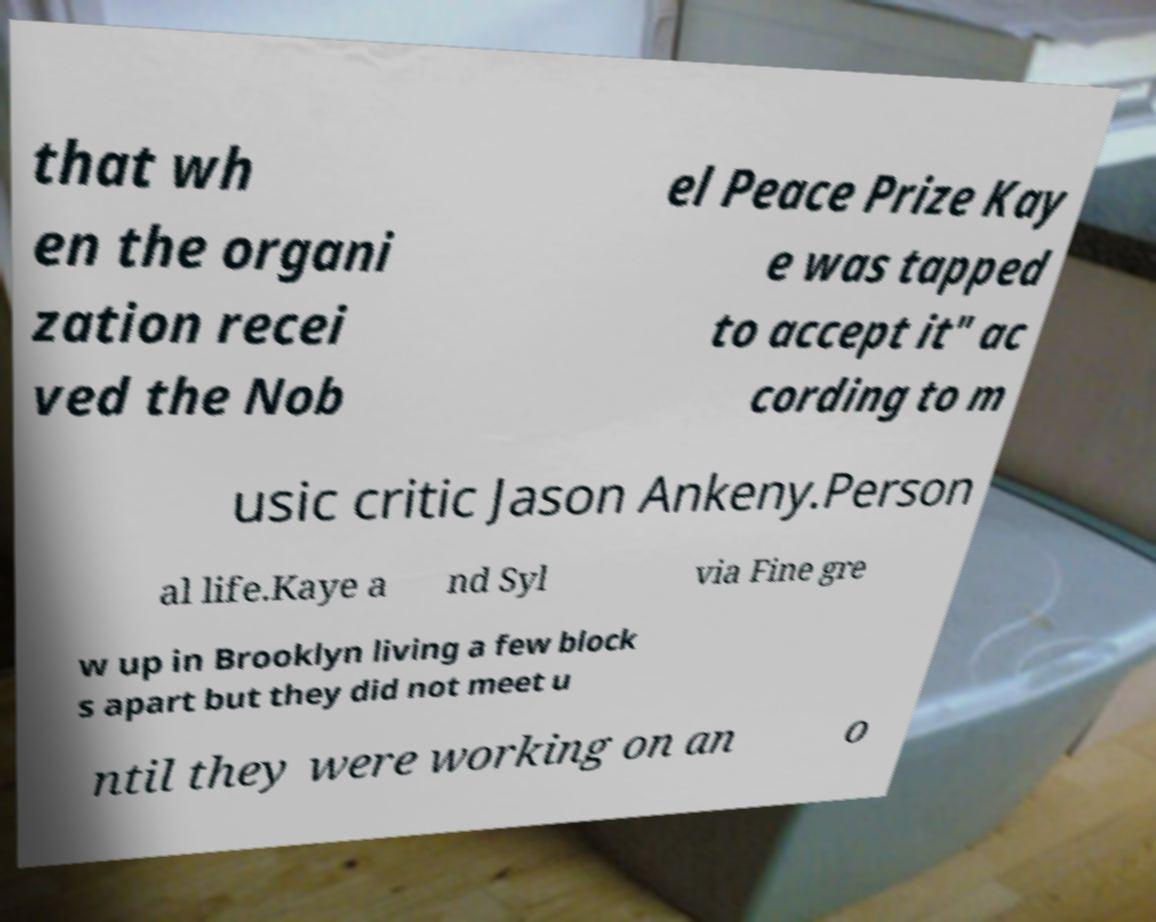What messages or text are displayed in this image? I need them in a readable, typed format. that wh en the organi zation recei ved the Nob el Peace Prize Kay e was tapped to accept it" ac cording to m usic critic Jason Ankeny.Person al life.Kaye a nd Syl via Fine gre w up in Brooklyn living a few block s apart but they did not meet u ntil they were working on an o 